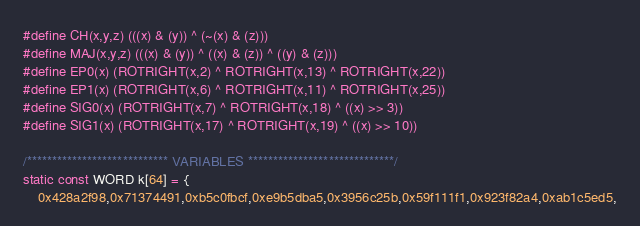Convert code to text. <code><loc_0><loc_0><loc_500><loc_500><_C++_>#define CH(x,y,z) (((x) & (y)) ^ (~(x) & (z)))
#define MAJ(x,y,z) (((x) & (y)) ^ ((x) & (z)) ^ ((y) & (z)))
#define EP0(x) (ROTRIGHT(x,2) ^ ROTRIGHT(x,13) ^ ROTRIGHT(x,22))
#define EP1(x) (ROTRIGHT(x,6) ^ ROTRIGHT(x,11) ^ ROTRIGHT(x,25))
#define SIG0(x) (ROTRIGHT(x,7) ^ ROTRIGHT(x,18) ^ ((x) >> 3))
#define SIG1(x) (ROTRIGHT(x,17) ^ ROTRIGHT(x,19) ^ ((x) >> 10))

/**************************** VARIABLES *****************************/
static const WORD k[64] = {
	0x428a2f98,0x71374491,0xb5c0fbcf,0xe9b5dba5,0x3956c25b,0x59f111f1,0x923f82a4,0xab1c5ed5,</code> 